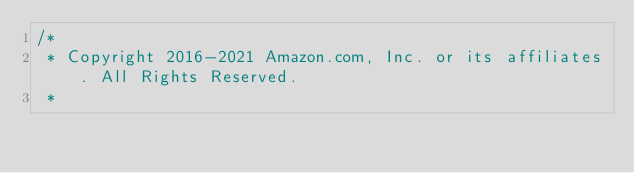<code> <loc_0><loc_0><loc_500><loc_500><_Java_>/*
 * Copyright 2016-2021 Amazon.com, Inc. or its affiliates. All Rights Reserved.
 * </code> 